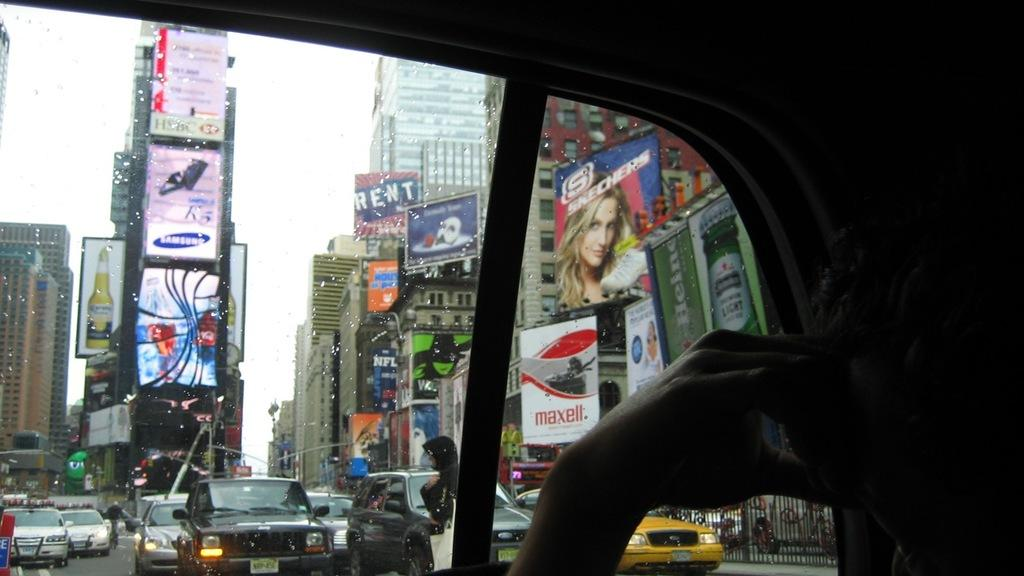Provide a one-sentence caption for the provided image. advertisements everywhere in the middle of the city in traffic. 